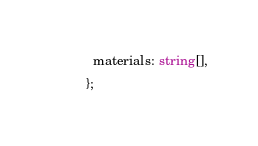<code> <loc_0><loc_0><loc_500><loc_500><_TypeScript_>  materials: string[],
};
</code> 